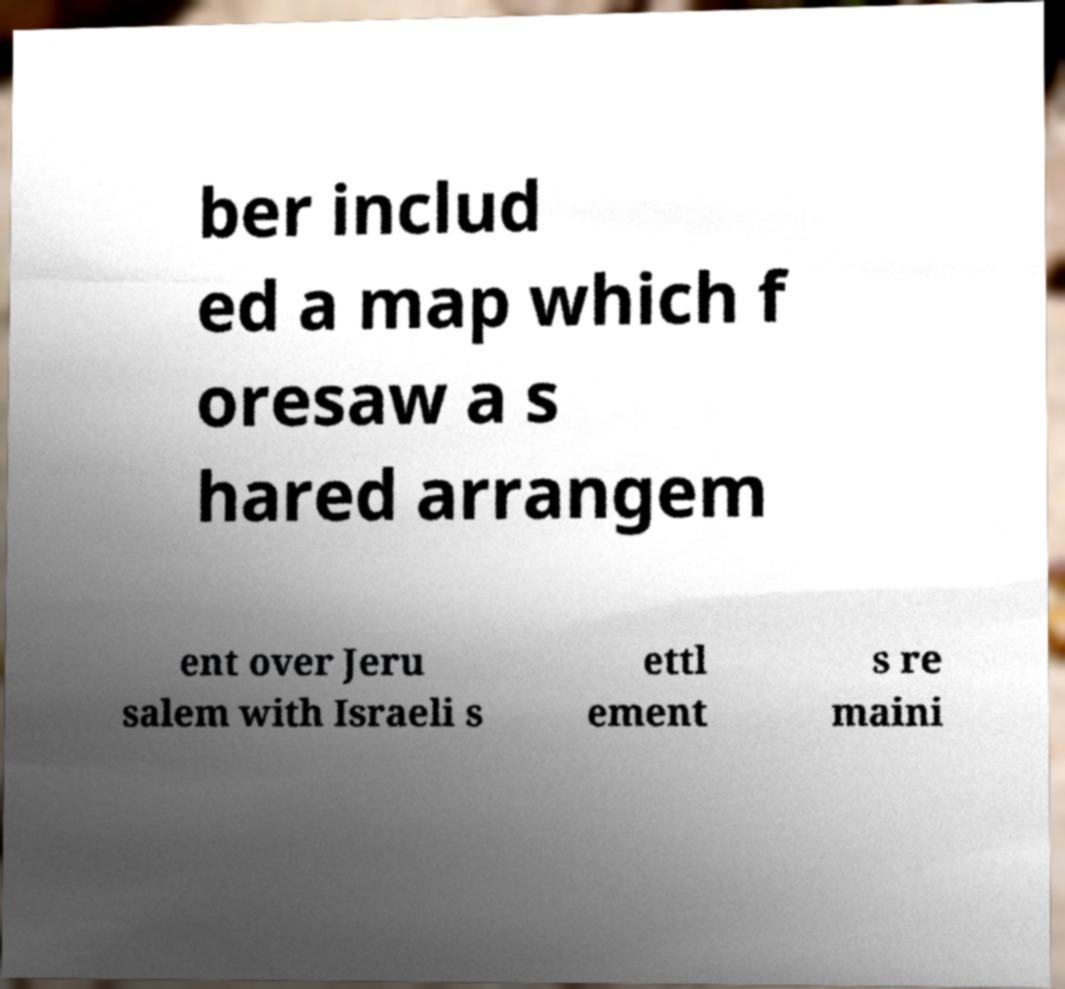Can you read and provide the text displayed in the image?This photo seems to have some interesting text. Can you extract and type it out for me? ber includ ed a map which f oresaw a s hared arrangem ent over Jeru salem with Israeli s ettl ement s re maini 